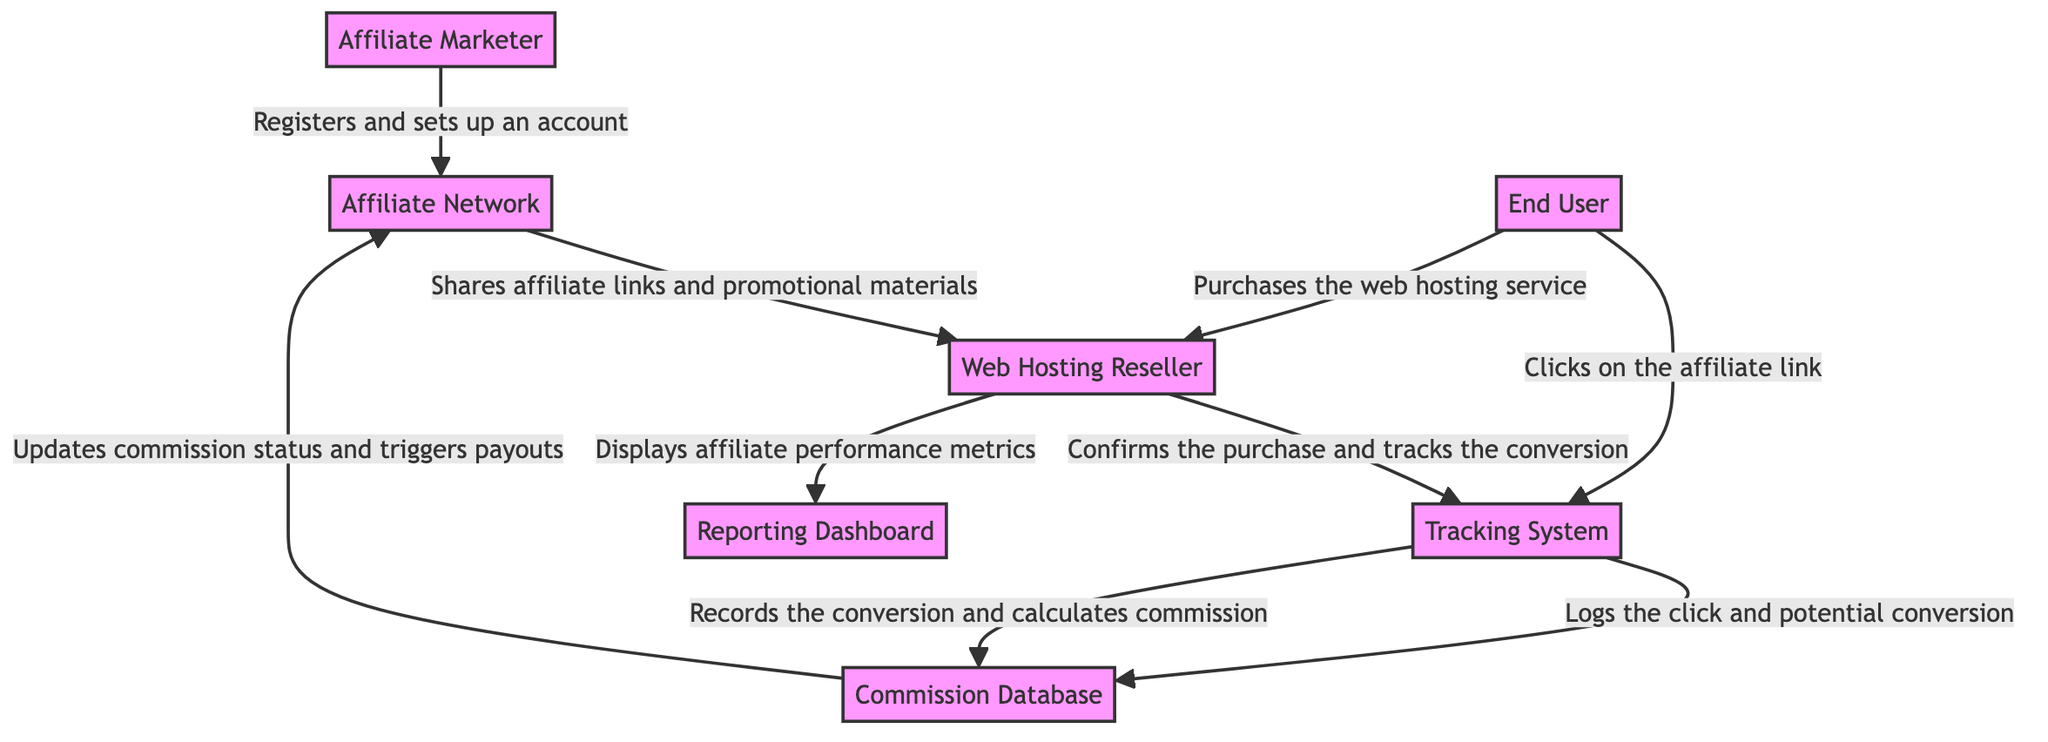What is the starting entity in the flow? The diagram begins with the Affiliate Marketer, who registers and sets up an account with the Affiliate Network.
Answer: Affiliate Marketer How many total entities are in the diagram? The diagram lists 7 distinct entities, including the Affiliate Marketer, Affiliate Network, Web Hosting Reseller, End User, Tracking System, Commission Database, and Reporting Dashboard.
Answer: 7 What is the first action performed by the End User? The End User clicks on the affiliate link, which initiates the interaction with the Tracking System.
Answer: Clicks on the affiliate link From which entity does the Reporting Dashboard receive data? The Reporting Dashboard receives performance metrics from the Web Hosting Reseller, which displays the results of affiliate activities.
Answer: Web Hosting Reseller What does the Tracking System do after logging a click? After the Tracking System logs a click by the End User, it proceeds to log the click and potential conversion into the Commission Database.
Answer: Logs the click and potential conversion Identify the final step in the commission process. The final step in the commission process is when the Commission Database updates commission status and triggers payouts to the Affiliate Network, completing the cycle.
Answer: Updates commission status and triggers payouts What action does the Web Hosting Reseller take to confirm a purchase? The Web Hosting Reseller confirms the purchase and tracks the conversion through the Tracking System after the End User makes a purchase.
Answer: Confirms the purchase and tracks the conversion Which entity shares promotional materials with the Web Hosting Reseller? The Affiliate Network shares the affiliate links and promotional materials with the Web Hosting Reseller, facilitating the marketing efforts.
Answer: Affiliate Network How does the Tracking System interact with the Commission Database? The Tracking System first logs the click and potential conversion, then records the actual conversion and calculates the commission in the Commission Database.
Answer: Logs the click and potential conversion; records the conversion and calculates commission 